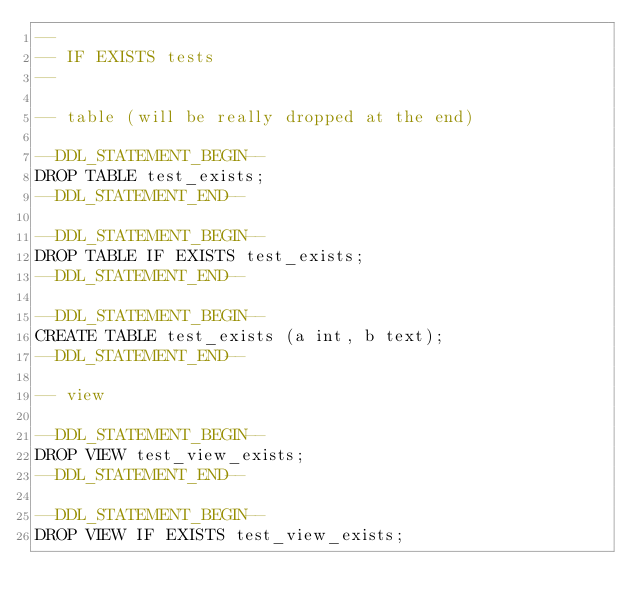<code> <loc_0><loc_0><loc_500><loc_500><_SQL_>--
-- IF EXISTS tests
--

-- table (will be really dropped at the end)

--DDL_STATEMENT_BEGIN--
DROP TABLE test_exists;
--DDL_STATEMENT_END--

--DDL_STATEMENT_BEGIN--
DROP TABLE IF EXISTS test_exists;
--DDL_STATEMENT_END--

--DDL_STATEMENT_BEGIN--
CREATE TABLE test_exists (a int, b text);
--DDL_STATEMENT_END--

-- view

--DDL_STATEMENT_BEGIN--
DROP VIEW test_view_exists;
--DDL_STATEMENT_END--

--DDL_STATEMENT_BEGIN--
DROP VIEW IF EXISTS test_view_exists;</code> 